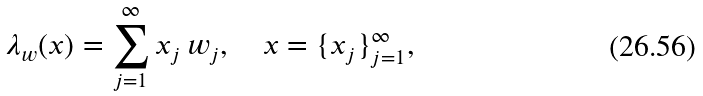Convert formula to latex. <formula><loc_0><loc_0><loc_500><loc_500>\lambda _ { w } ( x ) = \sum _ { j = 1 } ^ { \infty } x _ { j } \, w _ { j } , \quad x = \{ x _ { j } \} _ { j = 1 } ^ { \infty } ,</formula> 